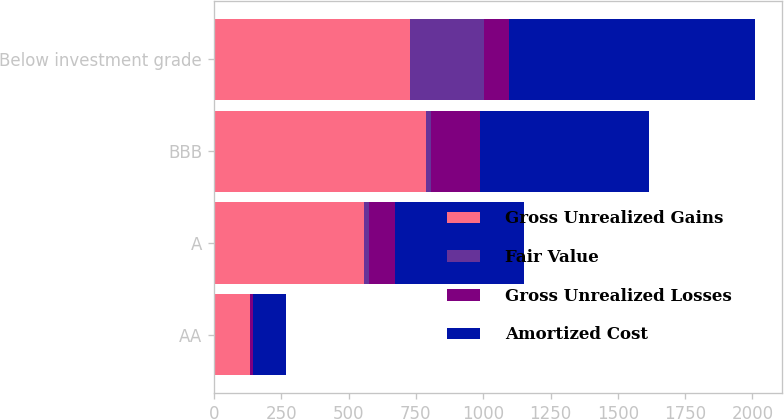Convert chart. <chart><loc_0><loc_0><loc_500><loc_500><stacked_bar_chart><ecel><fcel>AA<fcel>A<fcel>BBB<fcel>Below investment grade<nl><fcel>Gross Unrealized Gains<fcel>133<fcel>558<fcel>787<fcel>727<nl><fcel>Fair Value<fcel>1<fcel>17<fcel>21<fcel>277<nl><fcel>Gross Unrealized Losses<fcel>13<fcel>99<fcel>181<fcel>92<nl><fcel>Amortized Cost<fcel>121<fcel>476<fcel>627<fcel>912<nl></chart> 